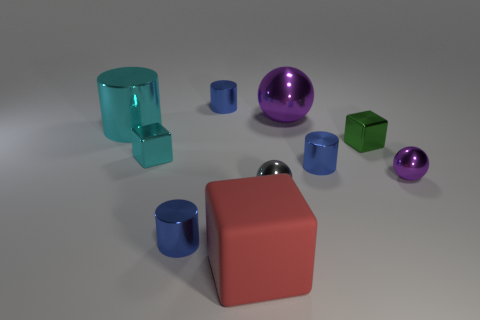The green shiny thing that is the same size as the gray object is what shape? The green shiny object, which appears to be comparable in size to the adjoining gray object, is a perfect representation of a cube, featuring six equal square faces and edges that come together at right angles to form its three-dimensional shape. 